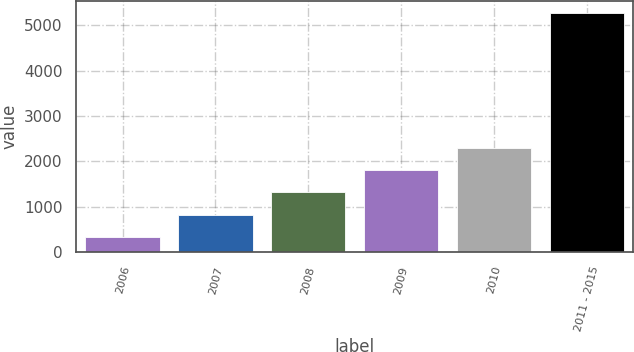Convert chart to OTSL. <chart><loc_0><loc_0><loc_500><loc_500><bar_chart><fcel>2006<fcel>2007<fcel>2008<fcel>2009<fcel>2010<fcel>2011 - 2015<nl><fcel>330<fcel>823.5<fcel>1317<fcel>1810.5<fcel>2304<fcel>5265<nl></chart> 